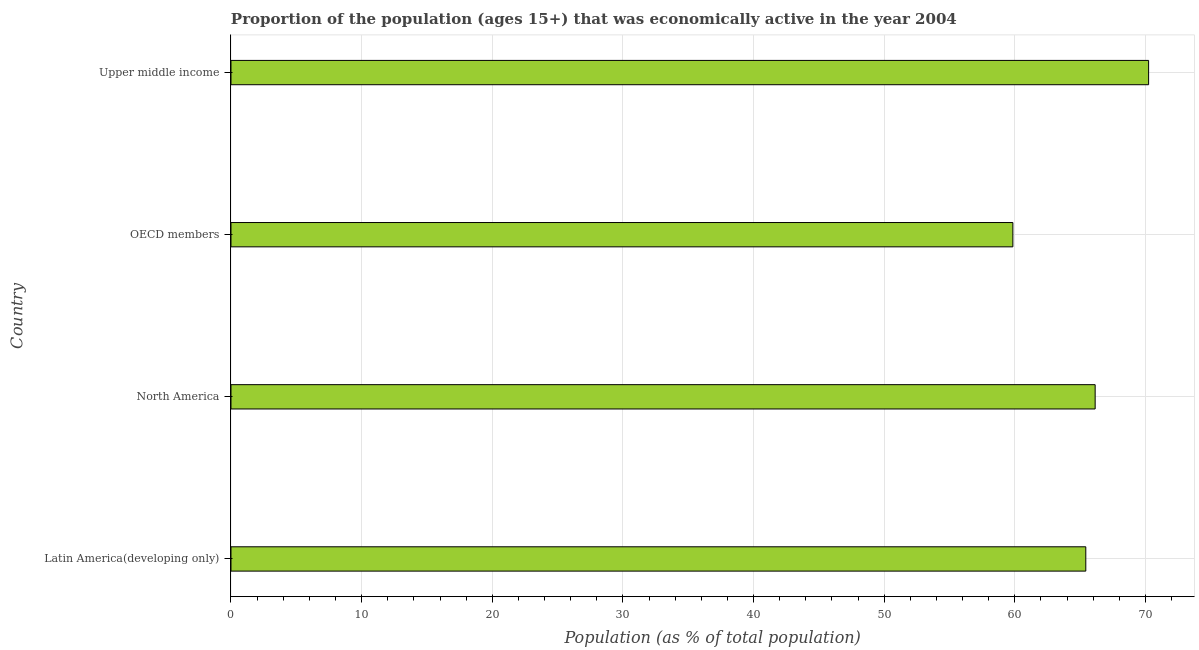Does the graph contain grids?
Give a very brief answer. Yes. What is the title of the graph?
Give a very brief answer. Proportion of the population (ages 15+) that was economically active in the year 2004. What is the label or title of the X-axis?
Offer a terse response. Population (as % of total population). What is the label or title of the Y-axis?
Your response must be concise. Country. What is the percentage of economically active population in Latin America(developing only)?
Offer a very short reply. 65.43. Across all countries, what is the maximum percentage of economically active population?
Your answer should be compact. 70.24. Across all countries, what is the minimum percentage of economically active population?
Your response must be concise. 59.85. In which country was the percentage of economically active population maximum?
Your response must be concise. Upper middle income. In which country was the percentage of economically active population minimum?
Your answer should be very brief. OECD members. What is the sum of the percentage of economically active population?
Ensure brevity in your answer.  261.68. What is the difference between the percentage of economically active population in OECD members and Upper middle income?
Offer a very short reply. -10.39. What is the average percentage of economically active population per country?
Provide a succinct answer. 65.42. What is the median percentage of economically active population?
Keep it short and to the point. 65.79. In how many countries, is the percentage of economically active population greater than 64 %?
Offer a very short reply. 3. What is the ratio of the percentage of economically active population in Latin America(developing only) to that in Upper middle income?
Make the answer very short. 0.93. What is the difference between the highest and the second highest percentage of economically active population?
Keep it short and to the point. 4.09. Is the sum of the percentage of economically active population in North America and Upper middle income greater than the maximum percentage of economically active population across all countries?
Offer a very short reply. Yes. What is the difference between the highest and the lowest percentage of economically active population?
Your response must be concise. 10.39. How many bars are there?
Offer a terse response. 4. How many countries are there in the graph?
Your answer should be compact. 4. Are the values on the major ticks of X-axis written in scientific E-notation?
Make the answer very short. No. What is the Population (as % of total population) of Latin America(developing only)?
Provide a succinct answer. 65.43. What is the Population (as % of total population) of North America?
Your answer should be compact. 66.15. What is the Population (as % of total population) of OECD members?
Provide a short and direct response. 59.85. What is the Population (as % of total population) in Upper middle income?
Offer a very short reply. 70.24. What is the difference between the Population (as % of total population) in Latin America(developing only) and North America?
Your answer should be compact. -0.72. What is the difference between the Population (as % of total population) in Latin America(developing only) and OECD members?
Provide a short and direct response. 5.58. What is the difference between the Population (as % of total population) in Latin America(developing only) and Upper middle income?
Ensure brevity in your answer.  -4.81. What is the difference between the Population (as % of total population) in North America and OECD members?
Your response must be concise. 6.3. What is the difference between the Population (as % of total population) in North America and Upper middle income?
Your response must be concise. -4.09. What is the difference between the Population (as % of total population) in OECD members and Upper middle income?
Give a very brief answer. -10.39. What is the ratio of the Population (as % of total population) in Latin America(developing only) to that in North America?
Keep it short and to the point. 0.99. What is the ratio of the Population (as % of total population) in Latin America(developing only) to that in OECD members?
Offer a terse response. 1.09. What is the ratio of the Population (as % of total population) in Latin America(developing only) to that in Upper middle income?
Offer a very short reply. 0.93. What is the ratio of the Population (as % of total population) in North America to that in OECD members?
Offer a terse response. 1.1. What is the ratio of the Population (as % of total population) in North America to that in Upper middle income?
Ensure brevity in your answer.  0.94. What is the ratio of the Population (as % of total population) in OECD members to that in Upper middle income?
Provide a succinct answer. 0.85. 